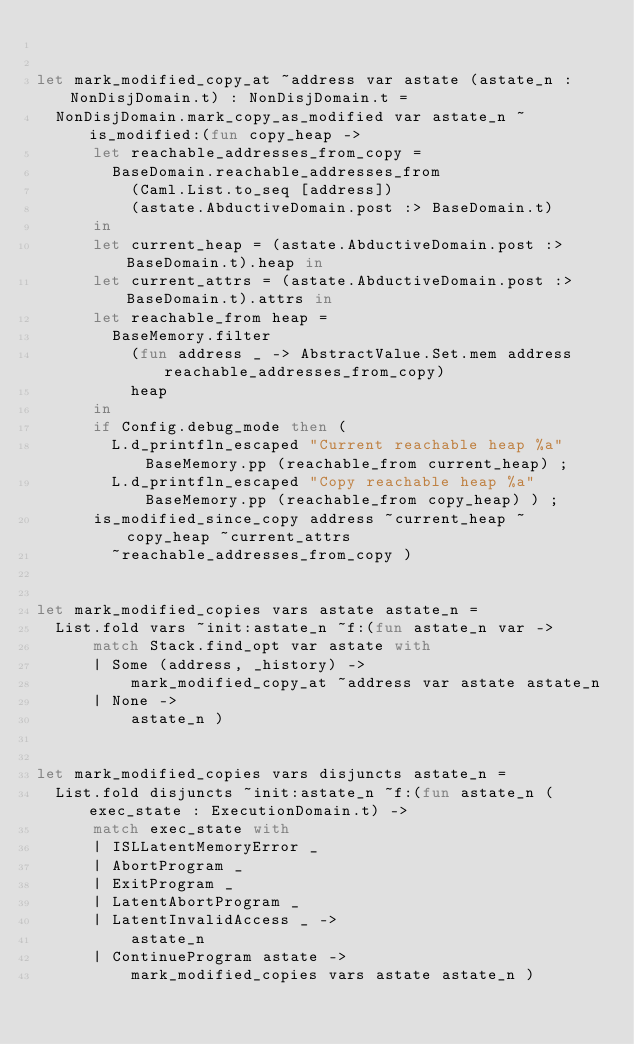<code> <loc_0><loc_0><loc_500><loc_500><_OCaml_>

let mark_modified_copy_at ~address var astate (astate_n : NonDisjDomain.t) : NonDisjDomain.t =
  NonDisjDomain.mark_copy_as_modified var astate_n ~is_modified:(fun copy_heap ->
      let reachable_addresses_from_copy =
        BaseDomain.reachable_addresses_from
          (Caml.List.to_seq [address])
          (astate.AbductiveDomain.post :> BaseDomain.t)
      in
      let current_heap = (astate.AbductiveDomain.post :> BaseDomain.t).heap in
      let current_attrs = (astate.AbductiveDomain.post :> BaseDomain.t).attrs in
      let reachable_from heap =
        BaseMemory.filter
          (fun address _ -> AbstractValue.Set.mem address reachable_addresses_from_copy)
          heap
      in
      if Config.debug_mode then (
        L.d_printfln_escaped "Current reachable heap %a" BaseMemory.pp (reachable_from current_heap) ;
        L.d_printfln_escaped "Copy reachable heap %a" BaseMemory.pp (reachable_from copy_heap) ) ;
      is_modified_since_copy address ~current_heap ~copy_heap ~current_attrs
        ~reachable_addresses_from_copy )


let mark_modified_copies vars astate astate_n =
  List.fold vars ~init:astate_n ~f:(fun astate_n var ->
      match Stack.find_opt var astate with
      | Some (address, _history) ->
          mark_modified_copy_at ~address var astate astate_n
      | None ->
          astate_n )


let mark_modified_copies vars disjuncts astate_n =
  List.fold disjuncts ~init:astate_n ~f:(fun astate_n (exec_state : ExecutionDomain.t) ->
      match exec_state with
      | ISLLatentMemoryError _
      | AbortProgram _
      | ExitProgram _
      | LatentAbortProgram _
      | LatentInvalidAccess _ ->
          astate_n
      | ContinueProgram astate ->
          mark_modified_copies vars astate astate_n )
</code> 